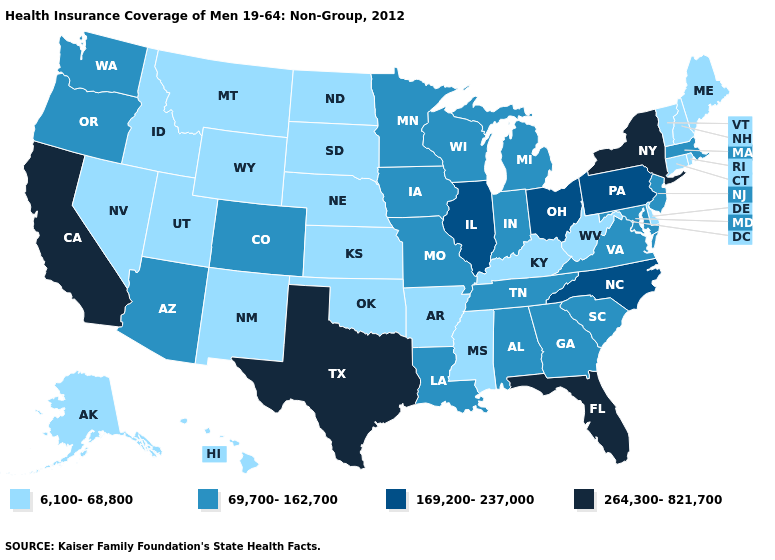Does Maine have the same value as Kansas?
Quick response, please. Yes. Name the states that have a value in the range 264,300-821,700?
Keep it brief. California, Florida, New York, Texas. Among the states that border Massachusetts , does Rhode Island have the lowest value?
Answer briefly. Yes. What is the lowest value in states that border Connecticut?
Write a very short answer. 6,100-68,800. Which states have the lowest value in the USA?
Keep it brief. Alaska, Arkansas, Connecticut, Delaware, Hawaii, Idaho, Kansas, Kentucky, Maine, Mississippi, Montana, Nebraska, Nevada, New Hampshire, New Mexico, North Dakota, Oklahoma, Rhode Island, South Dakota, Utah, Vermont, West Virginia, Wyoming. Among the states that border Virginia , does West Virginia have the lowest value?
Give a very brief answer. Yes. Name the states that have a value in the range 264,300-821,700?
Concise answer only. California, Florida, New York, Texas. Does Louisiana have the same value as Idaho?
Short answer required. No. Name the states that have a value in the range 169,200-237,000?
Write a very short answer. Illinois, North Carolina, Ohio, Pennsylvania. Does Texas have a higher value than New Mexico?
Concise answer only. Yes. Name the states that have a value in the range 6,100-68,800?
Write a very short answer. Alaska, Arkansas, Connecticut, Delaware, Hawaii, Idaho, Kansas, Kentucky, Maine, Mississippi, Montana, Nebraska, Nevada, New Hampshire, New Mexico, North Dakota, Oklahoma, Rhode Island, South Dakota, Utah, Vermont, West Virginia, Wyoming. What is the value of New Hampshire?
Be succinct. 6,100-68,800. Does Georgia have a higher value than Idaho?
Quick response, please. Yes. Does the map have missing data?
Short answer required. No. What is the highest value in the USA?
Write a very short answer. 264,300-821,700. 